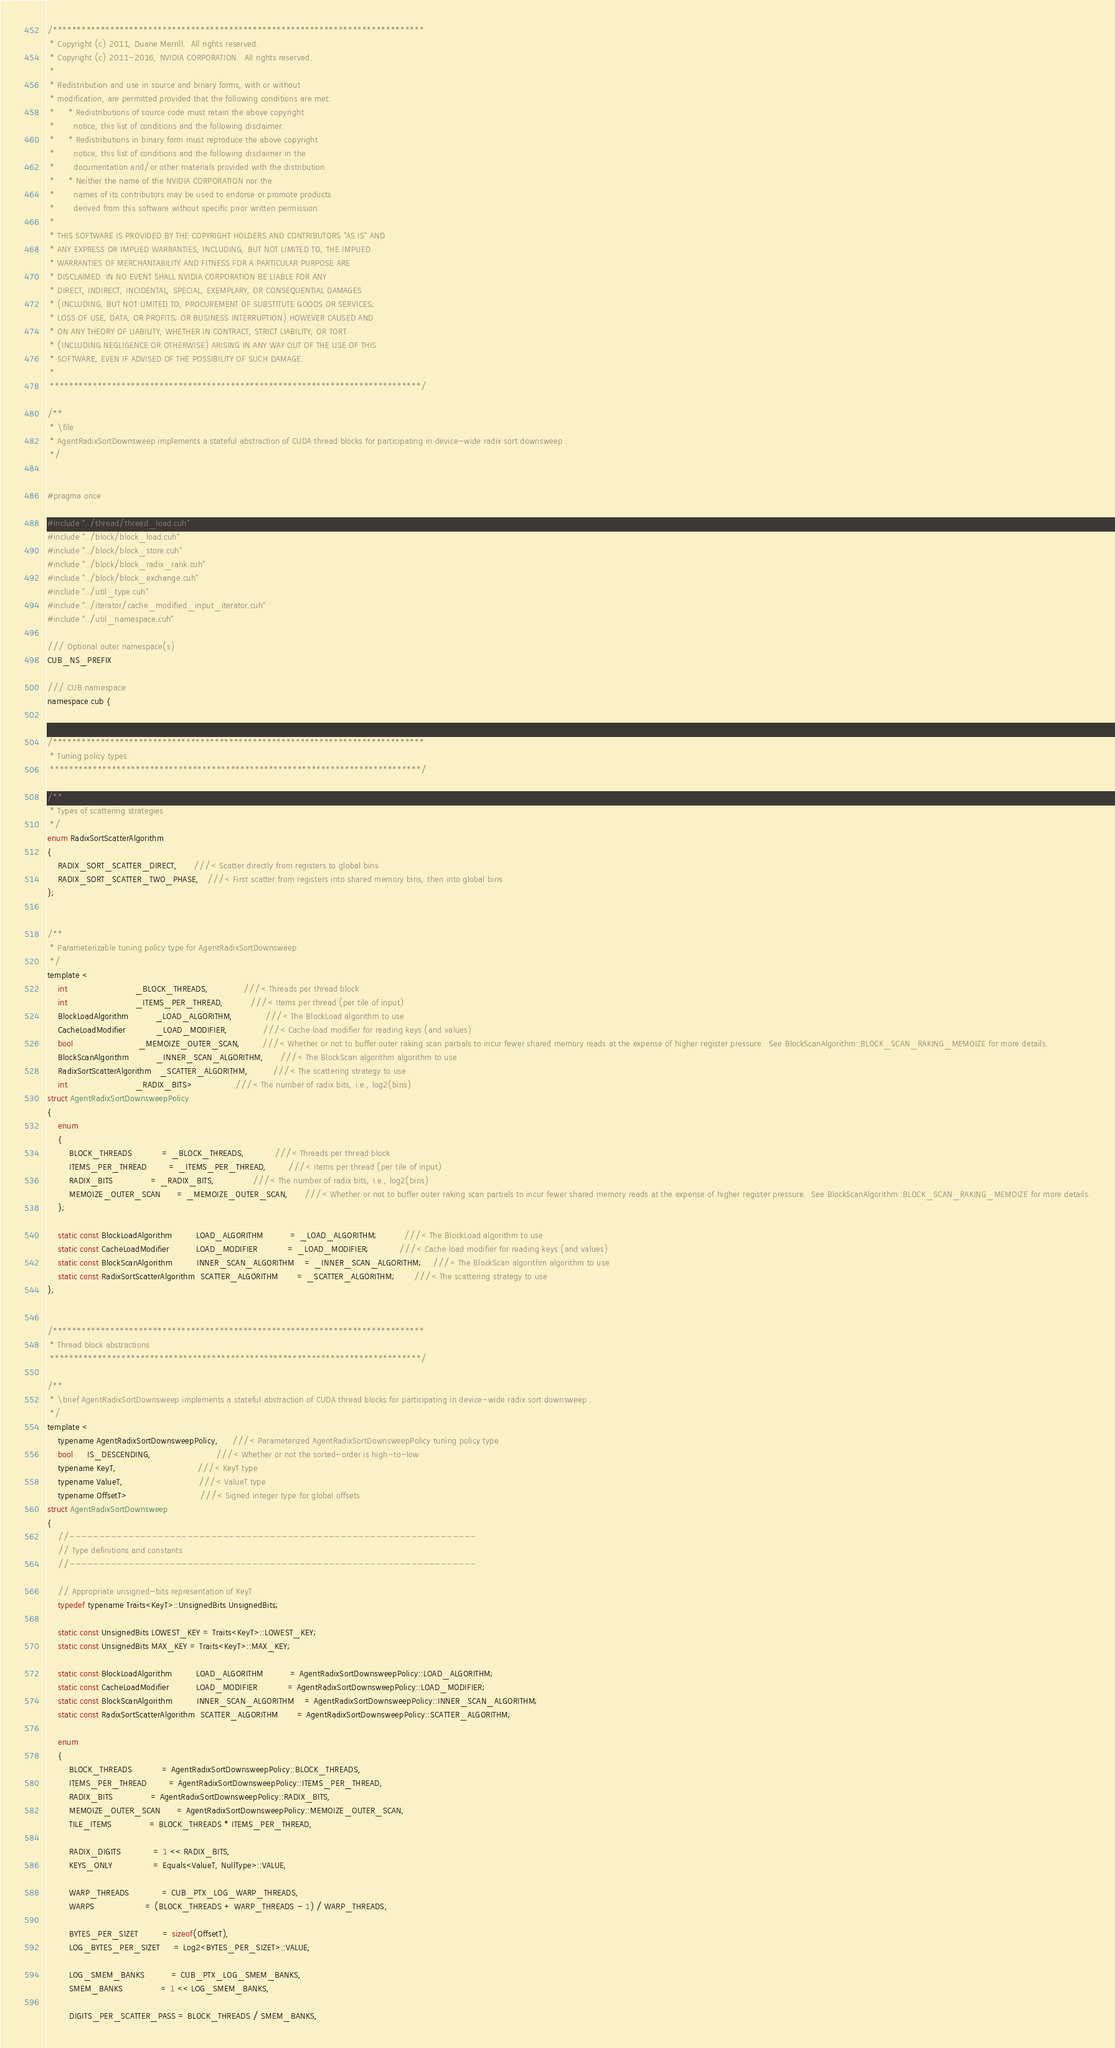Convert code to text. <code><loc_0><loc_0><loc_500><loc_500><_Cuda_>/******************************************************************************
 * Copyright (c) 2011, Duane Merrill.  All rights reserved.
 * Copyright (c) 2011-2016, NVIDIA CORPORATION.  All rights reserved.
 *
 * Redistribution and use in source and binary forms, with or without
 * modification, are permitted provided that the following conditions are met:
 *     * Redistributions of source code must retain the above copyright
 *       notice, this list of conditions and the following disclaimer.
 *     * Redistributions in binary form must reproduce the above copyright
 *       notice, this list of conditions and the following disclaimer in the
 *       documentation and/or other materials provided with the distribution.
 *     * Neither the name of the NVIDIA CORPORATION nor the
 *       names of its contributors may be used to endorse or promote products
 *       derived from this software without specific prior written permission.
 *
 * THIS SOFTWARE IS PROVIDED BY THE COPYRIGHT HOLDERS AND CONTRIBUTORS "AS IS" AND
 * ANY EXPRESS OR IMPLIED WARRANTIES, INCLUDING, BUT NOT LIMITED TO, THE IMPLIED
 * WARRANTIES OF MERCHANTABILITY AND FITNESS FOR A PARTICULAR PURPOSE ARE
 * DISCLAIMED. IN NO EVENT SHALL NVIDIA CORPORATION BE LIABLE FOR ANY
 * DIRECT, INDIRECT, INCIDENTAL, SPECIAL, EXEMPLARY, OR CONSEQUENTIAL DAMAGES
 * (INCLUDING, BUT NOT LIMITED TO, PROCUREMENT OF SUBSTITUTE GOODS OR SERVICES;
 * LOSS OF USE, DATA, OR PROFITS; OR BUSINESS INTERRUPTION) HOWEVER CAUSED AND
 * ON ANY THEORY OF LIABILITY, WHETHER IN CONTRACT, STRICT LIABILITY, OR TORT
 * (INCLUDING NEGLIGENCE OR OTHERWISE) ARISING IN ANY WAY OUT OF THE USE OF THIS
 * SOFTWARE, EVEN IF ADVISED OF THE POSSIBILITY OF SUCH DAMAGE.
 *
 ******************************************************************************/

/**
 * \file
 * AgentRadixSortDownsweep implements a stateful abstraction of CUDA thread blocks for participating in device-wide radix sort downsweep .
 */


#pragma once

#include "../thread/thread_load.cuh"
#include "../block/block_load.cuh"
#include "../block/block_store.cuh"
#include "../block/block_radix_rank.cuh"
#include "../block/block_exchange.cuh"
#include "../util_type.cuh"
#include "../iterator/cache_modified_input_iterator.cuh"
#include "../util_namespace.cuh"

/// Optional outer namespace(s)
CUB_NS_PREFIX

/// CUB namespace
namespace cub {


/******************************************************************************
 * Tuning policy types
 ******************************************************************************/

/**
 * Types of scattering strategies
 */
enum RadixSortScatterAlgorithm
{
    RADIX_SORT_SCATTER_DIRECT,      ///< Scatter directly from registers to global bins
    RADIX_SORT_SCATTER_TWO_PHASE,   ///< First scatter from registers into shared memory bins, then into global bins
};


/**
 * Parameterizable tuning policy type for AgentRadixSortDownsweep
 */
template <
    int                         _BLOCK_THREADS,             ///< Threads per thread block
    int                         _ITEMS_PER_THREAD,          ///< Items per thread (per tile of input)
    BlockLoadAlgorithm          _LOAD_ALGORITHM,            ///< The BlockLoad algorithm to use
    CacheLoadModifier           _LOAD_MODIFIER,             ///< Cache load modifier for reading keys (and values)
    bool                        _MEMOIZE_OUTER_SCAN,        ///< Whether or not to buffer outer raking scan partials to incur fewer shared memory reads at the expense of higher register pressure.  See BlockScanAlgorithm::BLOCK_SCAN_RAKING_MEMOIZE for more details.
    BlockScanAlgorithm          _INNER_SCAN_ALGORITHM,      ///< The BlockScan algorithm algorithm to use
    RadixSortScatterAlgorithm   _SCATTER_ALGORITHM,         ///< The scattering strategy to use
    int                         _RADIX_BITS>                ///< The number of radix bits, i.e., log2(bins)
struct AgentRadixSortDownsweepPolicy
{
    enum
    {
        BLOCK_THREADS           = _BLOCK_THREADS,           ///< Threads per thread block
        ITEMS_PER_THREAD        = _ITEMS_PER_THREAD,        ///< Items per thread (per tile of input)
        RADIX_BITS              = _RADIX_BITS,              ///< The number of radix bits, i.e., log2(bins)
        MEMOIZE_OUTER_SCAN      = _MEMOIZE_OUTER_SCAN,      ///< Whether or not to buffer outer raking scan partials to incur fewer shared memory reads at the expense of higher register pressure.  See BlockScanAlgorithm::BLOCK_SCAN_RAKING_MEMOIZE for more details.
    };

    static const BlockLoadAlgorithm         LOAD_ALGORITHM          = _LOAD_ALGORITHM;          ///< The BlockLoad algorithm to use
    static const CacheLoadModifier          LOAD_MODIFIER           = _LOAD_MODIFIER;           ///< Cache load modifier for reading keys (and values)
    static const BlockScanAlgorithm         INNER_SCAN_ALGORITHM    = _INNER_SCAN_ALGORITHM;    ///< The BlockScan algorithm algorithm to use
    static const RadixSortScatterAlgorithm  SCATTER_ALGORITHM       = _SCATTER_ALGORITHM;       ///< The scattering strategy to use
};


/******************************************************************************
 * Thread block abstractions
 ******************************************************************************/

/**
 * \brief AgentRadixSortDownsweep implements a stateful abstraction of CUDA thread blocks for participating in device-wide radix sort downsweep .
 */
template <
    typename AgentRadixSortDownsweepPolicy,     ///< Parameterized AgentRadixSortDownsweepPolicy tuning policy type
    bool     IS_DESCENDING,                        ///< Whether or not the sorted-order is high-to-low
    typename KeyT,                              ///< KeyT type
    typename ValueT,                            ///< ValueT type
    typename OffsetT>                           ///< Signed integer type for global offsets
struct AgentRadixSortDownsweep
{
    //---------------------------------------------------------------------
    // Type definitions and constants
    //---------------------------------------------------------------------

    // Appropriate unsigned-bits representation of KeyT
    typedef typename Traits<KeyT>::UnsignedBits UnsignedBits;

    static const UnsignedBits LOWEST_KEY = Traits<KeyT>::LOWEST_KEY;
    static const UnsignedBits MAX_KEY = Traits<KeyT>::MAX_KEY;

    static const BlockLoadAlgorithm         LOAD_ALGORITHM          = AgentRadixSortDownsweepPolicy::LOAD_ALGORITHM;
    static const CacheLoadModifier          LOAD_MODIFIER           = AgentRadixSortDownsweepPolicy::LOAD_MODIFIER;
    static const BlockScanAlgorithm         INNER_SCAN_ALGORITHM    = AgentRadixSortDownsweepPolicy::INNER_SCAN_ALGORITHM;
    static const RadixSortScatterAlgorithm  SCATTER_ALGORITHM       = AgentRadixSortDownsweepPolicy::SCATTER_ALGORITHM;

    enum
    {
        BLOCK_THREADS           = AgentRadixSortDownsweepPolicy::BLOCK_THREADS,
        ITEMS_PER_THREAD        = AgentRadixSortDownsweepPolicy::ITEMS_PER_THREAD,
        RADIX_BITS              = AgentRadixSortDownsweepPolicy::RADIX_BITS,
        MEMOIZE_OUTER_SCAN      = AgentRadixSortDownsweepPolicy::MEMOIZE_OUTER_SCAN,
        TILE_ITEMS              = BLOCK_THREADS * ITEMS_PER_THREAD,

        RADIX_DIGITS            = 1 << RADIX_BITS,
        KEYS_ONLY               = Equals<ValueT, NullType>::VALUE,

        WARP_THREADS            = CUB_PTX_LOG_WARP_THREADS,
        WARPS                   = (BLOCK_THREADS + WARP_THREADS - 1) / WARP_THREADS,

        BYTES_PER_SIZET         = sizeof(OffsetT),
        LOG_BYTES_PER_SIZET     = Log2<BYTES_PER_SIZET>::VALUE,

        LOG_SMEM_BANKS          = CUB_PTX_LOG_SMEM_BANKS,
        SMEM_BANKS              = 1 << LOG_SMEM_BANKS,

        DIGITS_PER_SCATTER_PASS = BLOCK_THREADS / SMEM_BANKS,</code> 